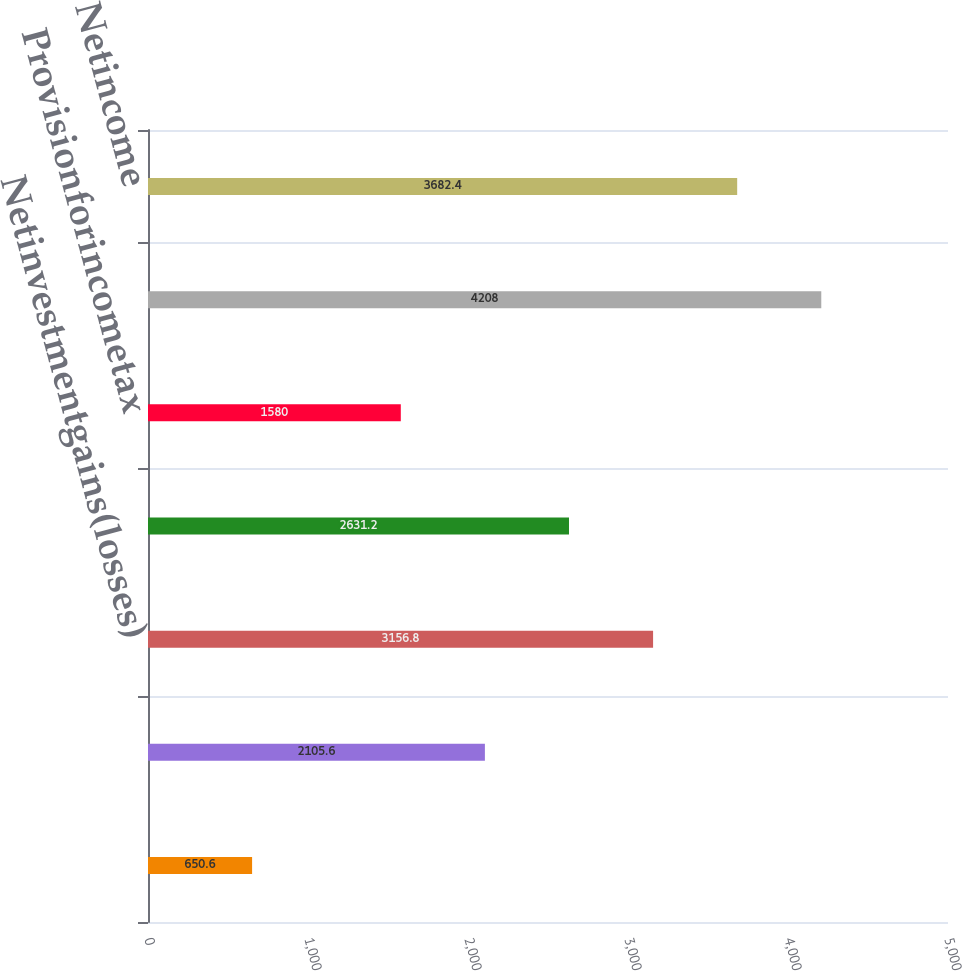<chart> <loc_0><loc_0><loc_500><loc_500><bar_chart><ecel><fcel>Otherrevenues<fcel>Netinvestmentgains(losses)<fcel>Policyholderdividends<fcel>Provisionforincometax<fcel>Incomefromcontinuingoperations<fcel>Netincome<nl><fcel>650.6<fcel>2105.6<fcel>3156.8<fcel>2631.2<fcel>1580<fcel>4208<fcel>3682.4<nl></chart> 